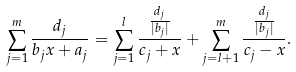<formula> <loc_0><loc_0><loc_500><loc_500>\sum _ { j = 1 } ^ { m } \frac { d _ { j } } { b _ { j } x + a _ { j } } = \sum _ { j = 1 } ^ { l } \frac { \frac { d _ { j } } { | b _ { j } | } } { c _ { j } + x } + \sum _ { j = l + 1 } ^ { m } \frac { \frac { d _ { j } } { | b _ { j } | } } { c _ { j } - x } .</formula> 